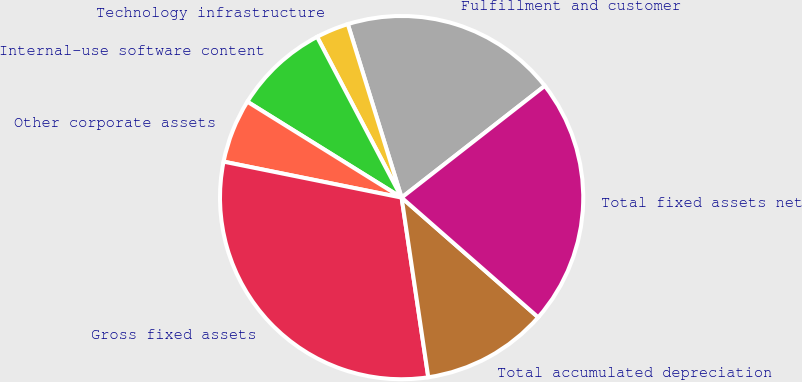<chart> <loc_0><loc_0><loc_500><loc_500><pie_chart><fcel>Fulfillment and customer<fcel>Technology infrastructure<fcel>Internal-use software content<fcel>Other corporate assets<fcel>Gross fixed assets<fcel>Total accumulated depreciation<fcel>Total fixed assets net<nl><fcel>19.24%<fcel>2.92%<fcel>8.44%<fcel>5.68%<fcel>30.52%<fcel>11.2%<fcel>22.0%<nl></chart> 